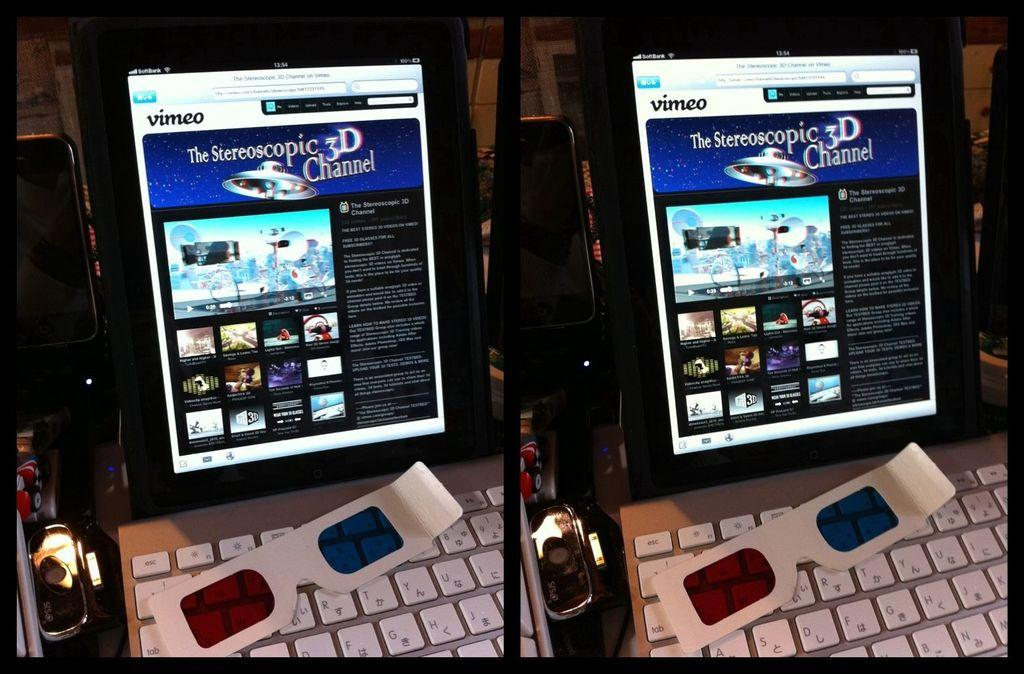<image>
Render a clear and concise summary of the photo. A digital display showing a vimeo website featuring 3D channel. 